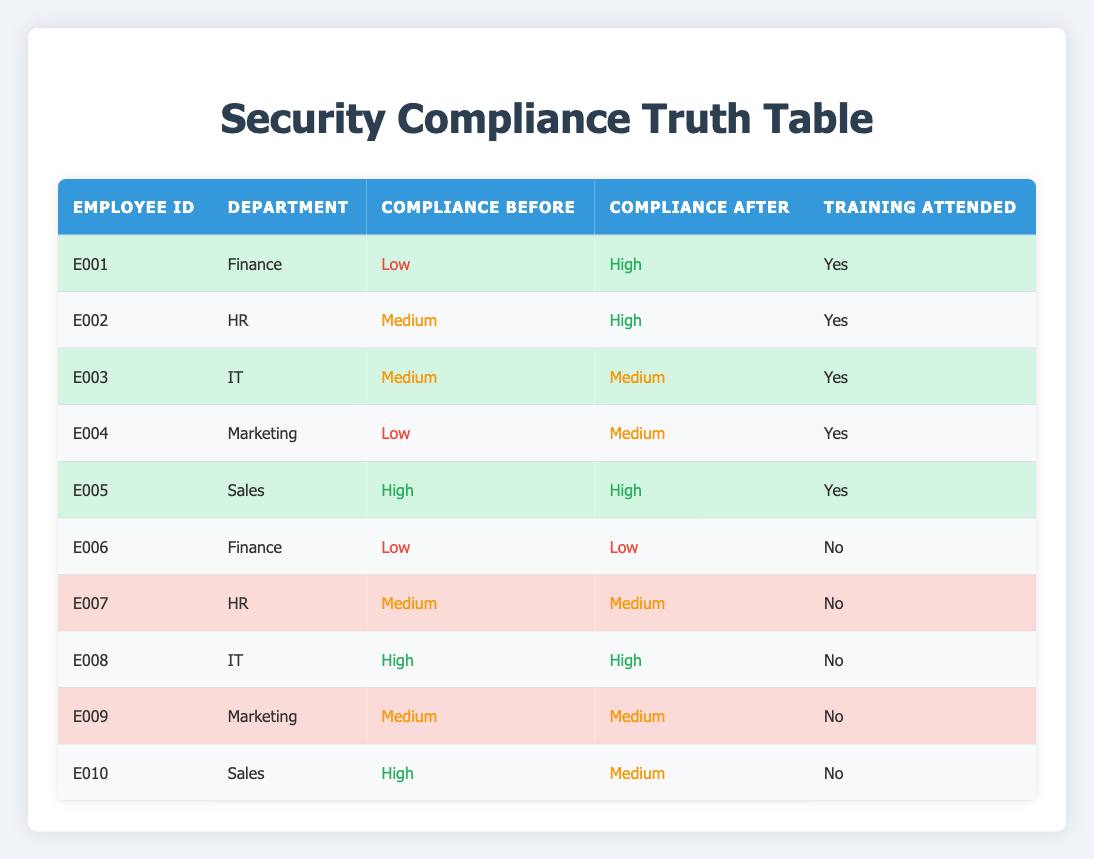What was the compliance level of employee E001 before the training? Looking at the table, I locate employee E001 and check the "Compliance Before" column. The value listed is "Low."
Answer: Low How many employees attended the training and showed an improvement in their compliance level? I will identify all employees with "Training Attended" marked as yes and then check their "Compliance Before" and "Compliance After" columns. E001 (Low to High), E002 (Medium to High), E004 (Low to Medium) show improvement. Therefore, there are 3 employees.
Answer: 3 Is there any employee who attended the training but did not improve their compliance level? I need to review employees who attended the training ("Training Attended" is yes) and compare their "Compliance Before" and "Compliance After" values. Employee E003 (Medium to Medium) did not show any improvement.
Answer: Yes What is the compliance level of employees after training in the Sales department? I will focus on the Sales department entries and check the "Compliance After" column. E005 remains "High" and E010 changed from "High" to "Medium," so the compliance levels after training are High and Medium.
Answer: High, Medium Which department has the highest percentage of employees showing improvement after the training? First, I check each department's employees who attended training and see improvements. Finance has 2 employees (E001, E006), with 1 improved (50%). HR has 2 employees (E002, E007), with 1 improved (50%). IT has 2 employees (E003, E008), with 0 improved (0%). Marketing has 2 employees (E004, E009), with 1 improved (50%). Sales has 2 employees (E005, E010), with 1 improved (50%). Since all departments have 50%, there is no highest percentage.
Answer: None What was the overall compliance change for employees who did not attend training? I will identify the employees who did not attend training and assess their compliance levels before and after. E006 (Low to Low), E007 (Medium to Medium), E008 (High to High), E009 (Medium to Medium), E010 (High to Medium). Summarizing, there was no positive change for any of them.
Answer: No change 